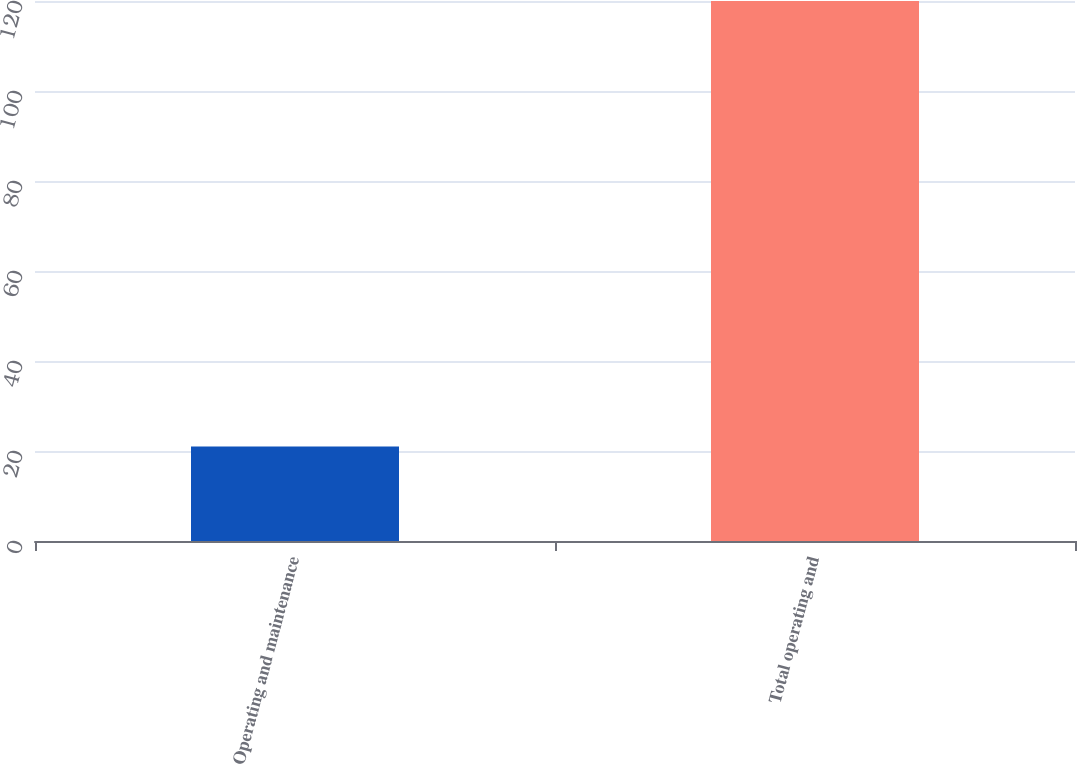Convert chart. <chart><loc_0><loc_0><loc_500><loc_500><bar_chart><fcel>Operating and maintenance<fcel>Total operating and<nl><fcel>21<fcel>120<nl></chart> 